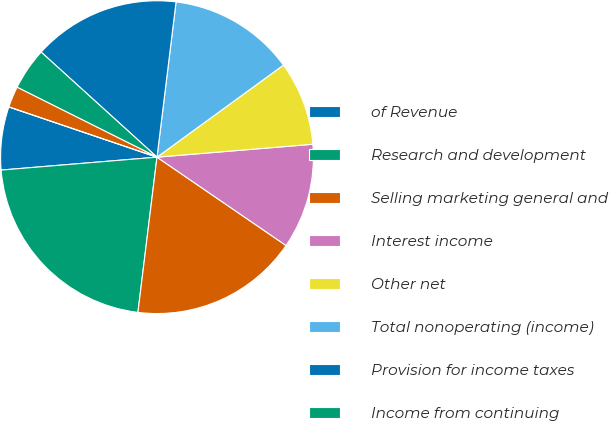<chart> <loc_0><loc_0><loc_500><loc_500><pie_chart><fcel>of Revenue<fcel>Research and development<fcel>Selling marketing general and<fcel>Interest income<fcel>Other net<fcel>Total nonoperating (income)<fcel>Provision for income taxes<fcel>Income from continuing<fcel>Net income<fcel>Dividends declared per share<nl><fcel>6.52%<fcel>21.74%<fcel>17.39%<fcel>10.87%<fcel>8.7%<fcel>13.04%<fcel>15.22%<fcel>4.35%<fcel>2.17%<fcel>0.0%<nl></chart> 